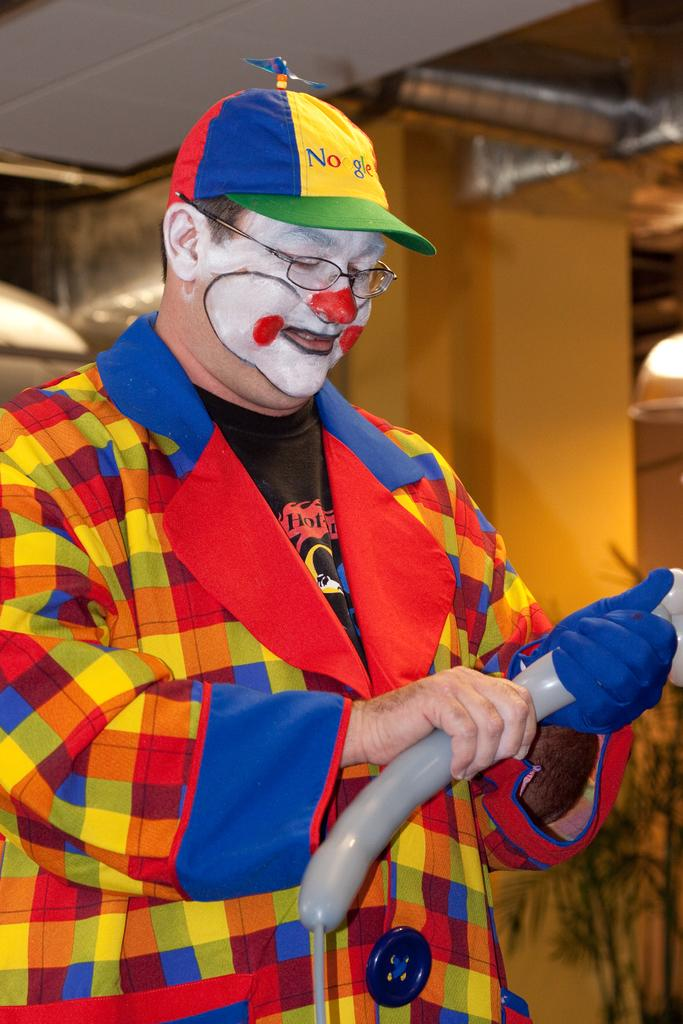Who is present in the image? There is a man in the image. What accessories is the man wearing? The man is wearing spectacles and a cap. What is the man holding in the image? The man is holding a balloon. What can be seen in the background of the image? There are lights and a wall in the background of the image. What type of desk can be seen in the image? There is no desk present in the image. Is the man accompanied by a cow in the image? No, there is no cow present in the image. 